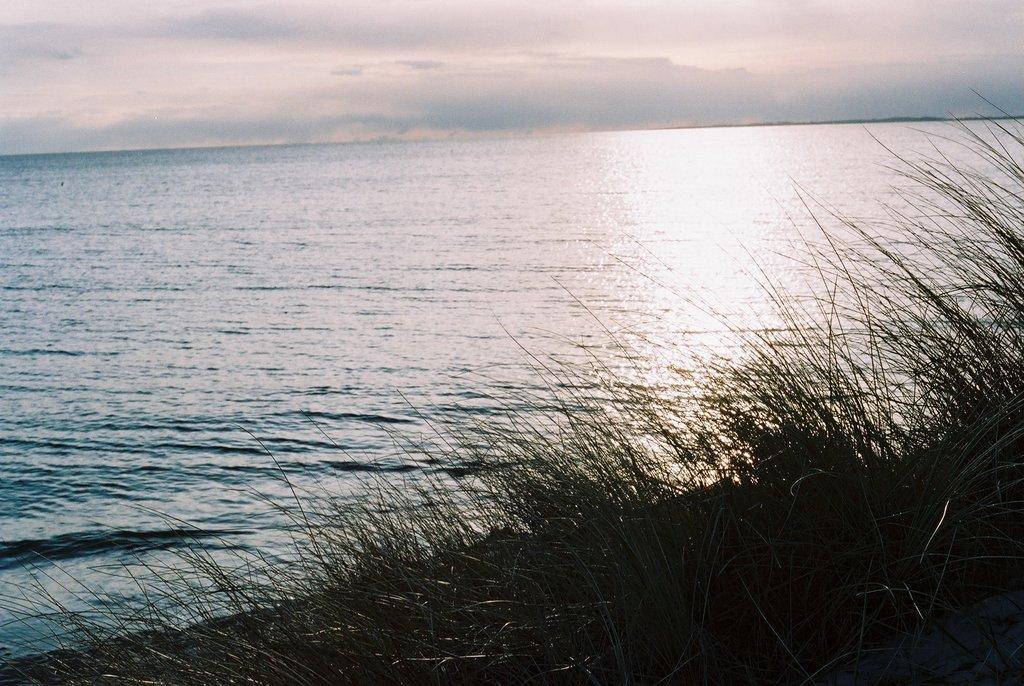Could you give a brief overview of what you see in this image? In the picture I can see the ocean. I can see the green grass at the bottom of the picture. There are clouds in the sky. 